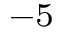<formula> <loc_0><loc_0><loc_500><loc_500>^ { - 5 }</formula> 